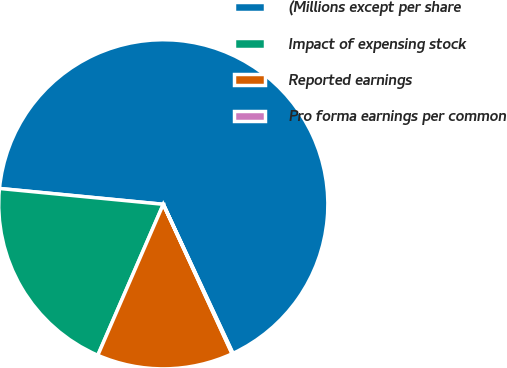Convert chart. <chart><loc_0><loc_0><loc_500><loc_500><pie_chart><fcel>(Millions except per share<fcel>Impact of expensing stock<fcel>Reported earnings<fcel>Pro forma earnings per common<nl><fcel>66.51%<fcel>20.02%<fcel>13.38%<fcel>0.09%<nl></chart> 